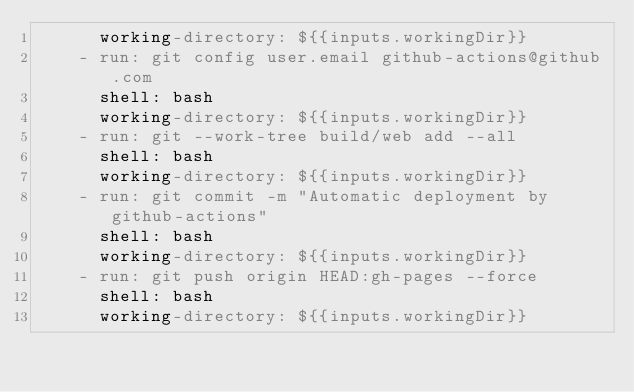Convert code to text. <code><loc_0><loc_0><loc_500><loc_500><_YAML_>      working-directory: ${{inputs.workingDir}}
    - run: git config user.email github-actions@github.com
      shell: bash
      working-directory: ${{inputs.workingDir}}
    - run: git --work-tree build/web add --all
      shell: bash
      working-directory: ${{inputs.workingDir}}
    - run: git commit -m "Automatic deployment by github-actions"
      shell: bash
      working-directory: ${{inputs.workingDir}}
    - run: git push origin HEAD:gh-pages --force
      shell: bash
      working-directory: ${{inputs.workingDir}}
</code> 